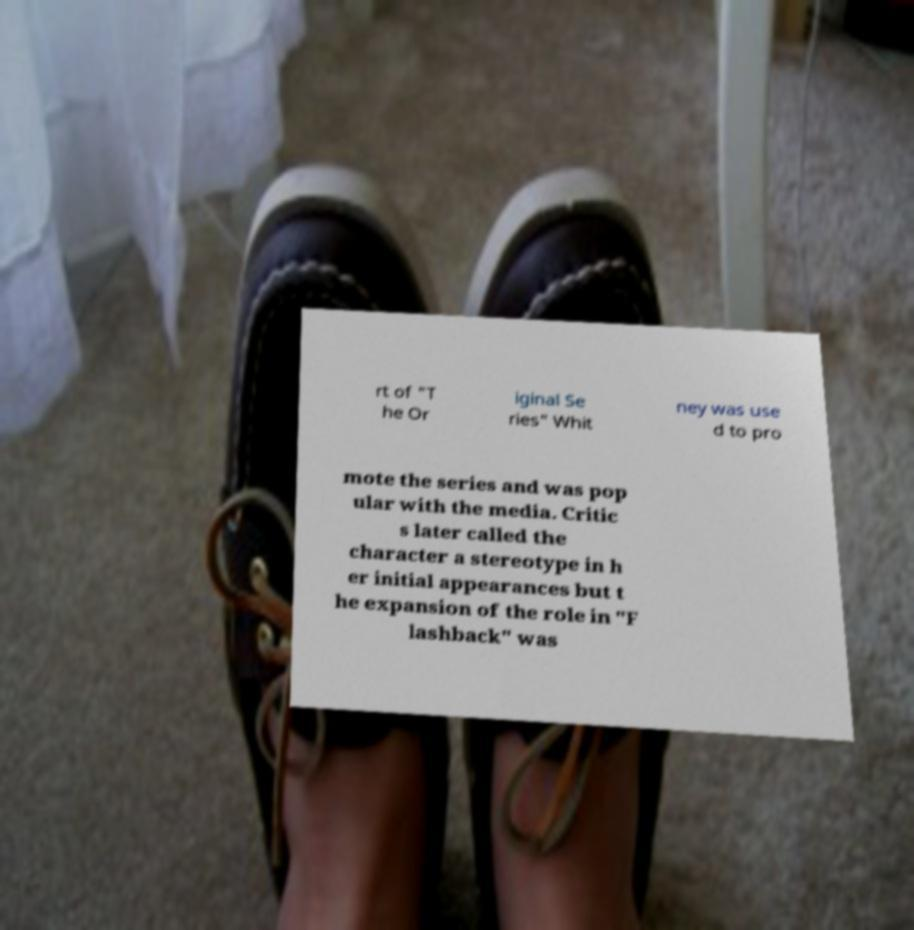Please read and relay the text visible in this image. What does it say? rt of "T he Or iginal Se ries" Whit ney was use d to pro mote the series and was pop ular with the media. Critic s later called the character a stereotype in h er initial appearances but t he expansion of the role in "F lashback" was 